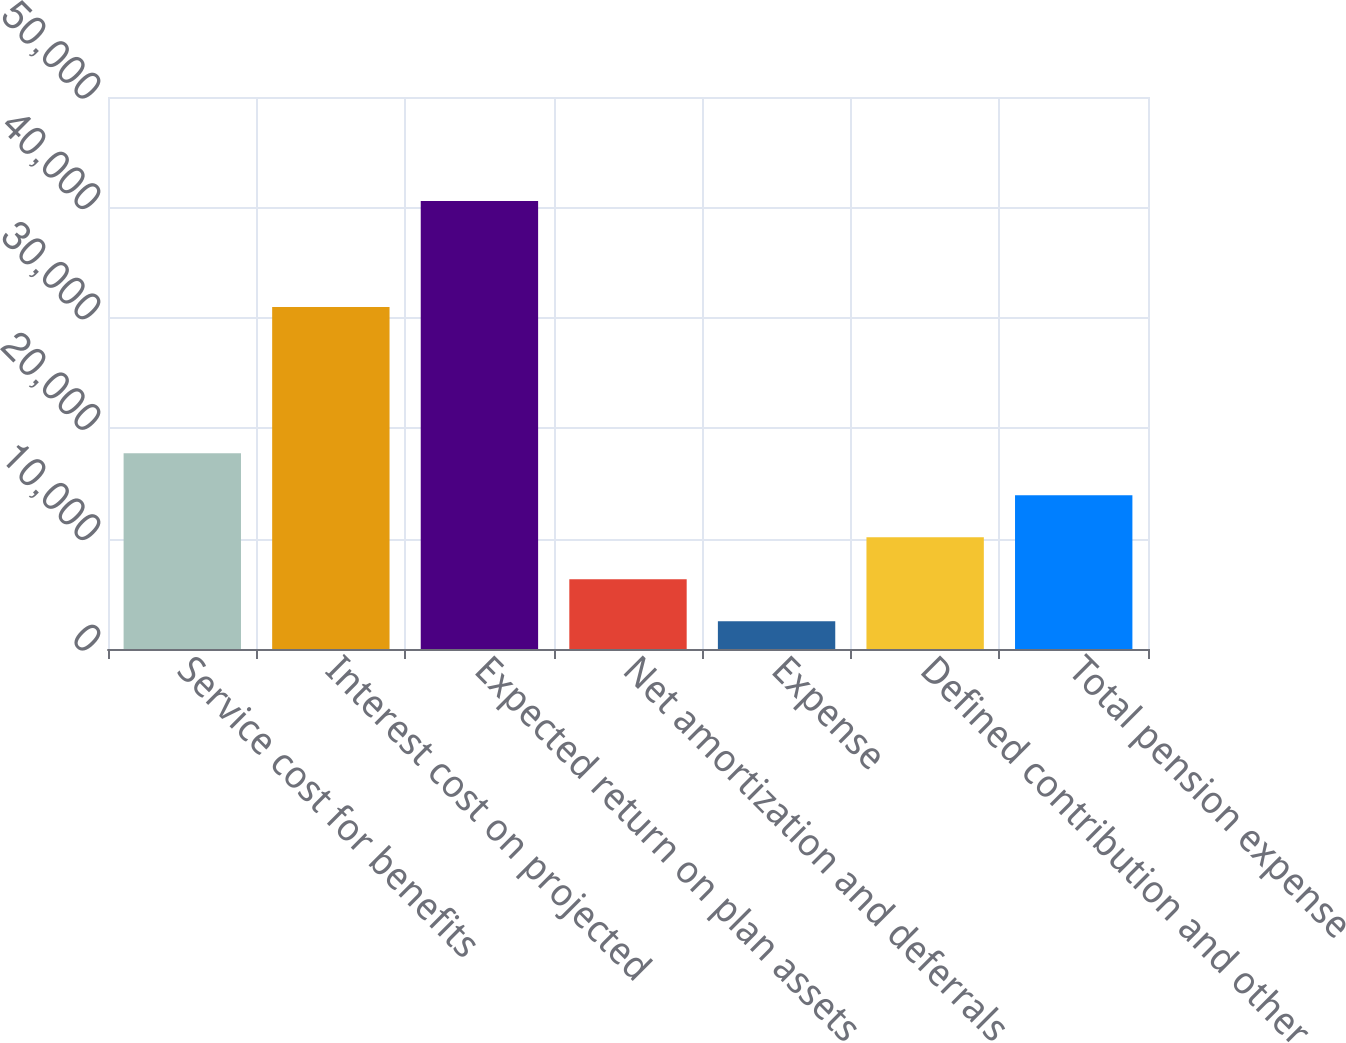Convert chart to OTSL. <chart><loc_0><loc_0><loc_500><loc_500><bar_chart><fcel>Service cost for benefits<fcel>Interest cost on projected<fcel>Expected return on plan assets<fcel>Net amortization and deferrals<fcel>Expense<fcel>Defined contribution and other<fcel>Total pension expense<nl><fcel>17742.2<fcel>30978<fcel>40589<fcel>6318.8<fcel>2511<fcel>10126.6<fcel>13934.4<nl></chart> 